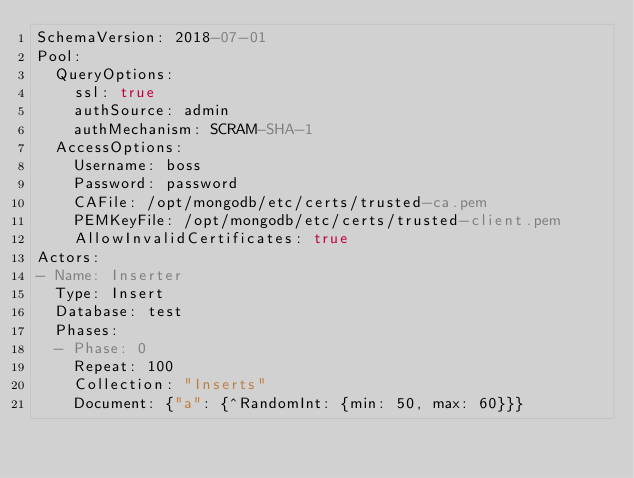<code> <loc_0><loc_0><loc_500><loc_500><_YAML_>SchemaVersion: 2018-07-01
Pool:
  QueryOptions:
    ssl: true
    authSource: admin
    authMechanism: SCRAM-SHA-1
  AccessOptions:
    Username: boss
    Password: password
    CAFile: /opt/mongodb/etc/certs/trusted-ca.pem
    PEMKeyFile: /opt/mongodb/etc/certs/trusted-client.pem
    AllowInvalidCertificates: true
Actors:
- Name: Inserter
  Type: Insert
  Database: test
  Phases:
  - Phase: 0
    Repeat: 100
    Collection: "Inserts"
    Document: {"a": {^RandomInt: {min: 50, max: 60}}}

</code> 